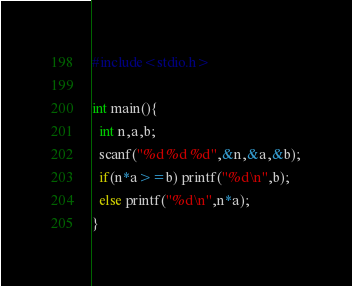Convert code to text. <code><loc_0><loc_0><loc_500><loc_500><_C_>#include<stdio.h>

int main(){
  int n,a,b;
  scanf("%d %d %d",&n,&a,&b);
  if(n*a>=b) printf("%d\n",b);
  else printf("%d\n",n*a);
}
</code> 